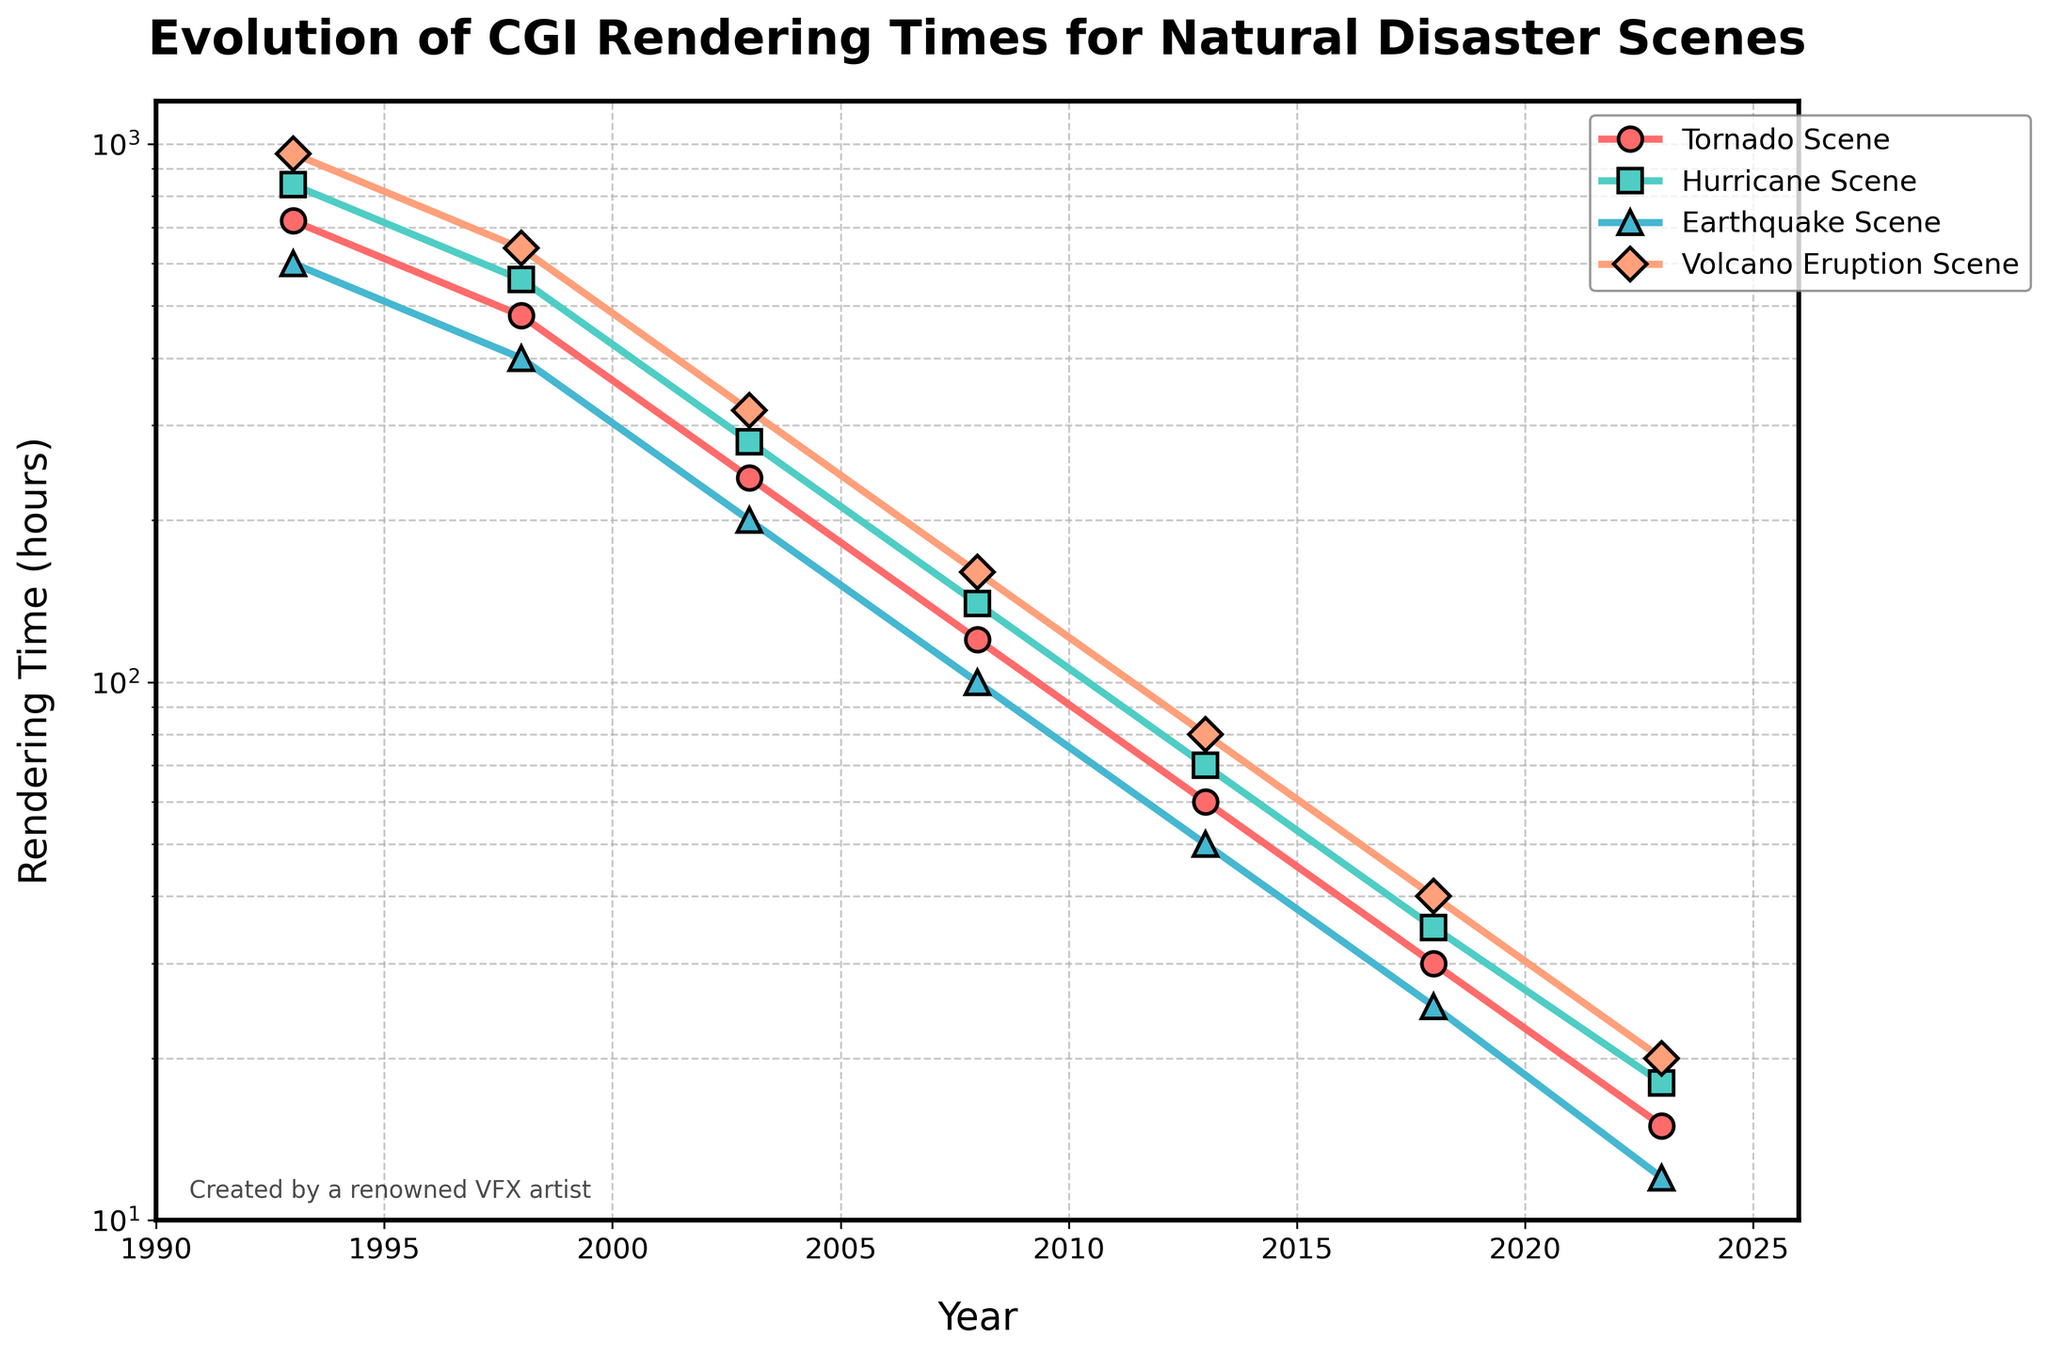What year saw the most significant drop in rendering times for Volcanic Eruption scenes? By observing the trend of the 'Volcano Eruption Scene', the most significant drop happened between 1993 (960 hours) and 1998 (640 hours). The decrease is 320 hours.
Answer: 1998 How many years did it take for the rendering time of Tornado scenes to go from 720 hours to 15 hours? The rendering time for Tornado scenes decreased from 720 hours in 1993 to 15 hours in 2023. To find the number of years, we subtract 1993 from 2023. 2023 - 1993 = 30 years.
Answer: 30 years Which scene had the least rendering time in 2018? In 2018, the rendering times for Tornado, Hurricane, Earthquake, and Volcano Eruption scenes are 30, 35, 25, and 40 hours respectively. The Earthquake scene had the least rendering time with 25 hours.
Answer: Earthquake Scene By what factor has the rendering time for an Earthquake scene reduced from 1993 to 2023? The rendering time for an Earthquake scene in 1993 was 600 hours and in 2023 it was 12 hours. The factor of reduction can be found by dividing 600 by 12. 600 / 12 = 50.
Answer: 50 Compare the rendering times for the Hurricane Scene and Earthquake Scene in 2008. Which one was higher and by how much? In 2008, the Hurricane Scene took 140 hours and the Earthquake Scene took 100 hours. The difference is 140 - 100, which equals 40 hours. Therefore, the Hurricane Scene had a higher rendering time by 40 hours.
Answer: Hurricane Scene was higher by 40 hours When did the rendering times for Tornado scenes first fall below 100 hours? Looking at the trend for Tornado scenes, the time falls below 100 hours for the first time in 2013 when it was recorded as 60 hours.
Answer: 2013 Sum the rendering times of all four scenes in the year 2003. For 2003, the rendering times for Tornado, Hurricane, Earthquake, and Volcano Eruption scenes are 240, 280, 200, and 320 hours respectively. The sum is 240 + 280 + 200 + 320 = 1040 hours.
Answer: 1040 hours In which year do all four scenes show rendering times of below 50 hours? Studying the data, 2018 is the year where all four scenes (Tornado: 30 hours, Hurricane: 35 hours, Earthquake: 25 hours, Volcano Eruption: 40 hours) show rendering times below 50 hours.
Answer: 2018 What is the average rendering time for the Volcano Eruption scene across all the given years? Adding up the rendering times for the Volcano Eruption Scene in all the given years we get: 960 + 640 + 320 + 160 + 80 + 40 + 20 = 2220 hours. There are 7 data points, so the average is 2220 / 7 = 317.14 hours.
Answer: 317.14 hours 